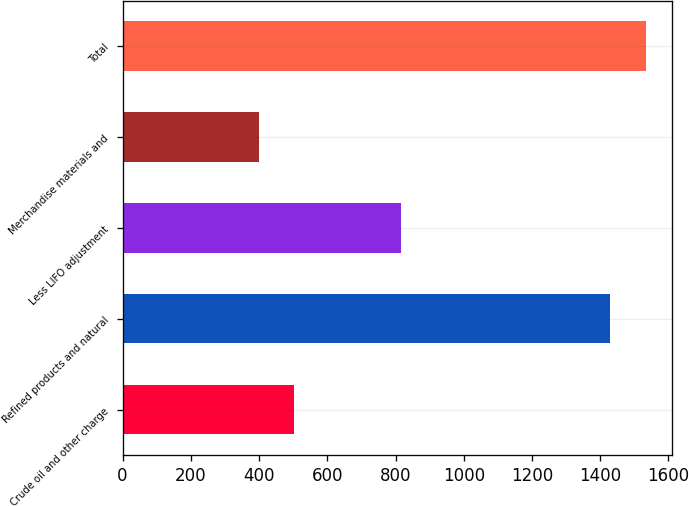Convert chart. <chart><loc_0><loc_0><loc_500><loc_500><bar_chart><fcel>Crude oil and other charge<fcel>Refined products and natural<fcel>Less LIFO adjustment<fcel>Merchandise materials and<fcel>Total<nl><fcel>503.8<fcel>1429<fcel>815<fcel>400<fcel>1532.8<nl></chart> 